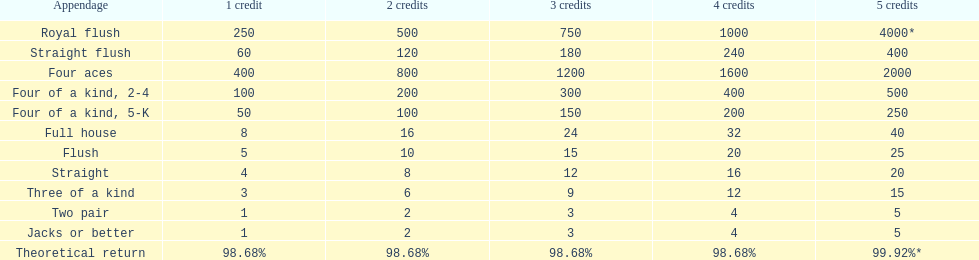After winning on four credits with a full house, what is your payout? 32. 